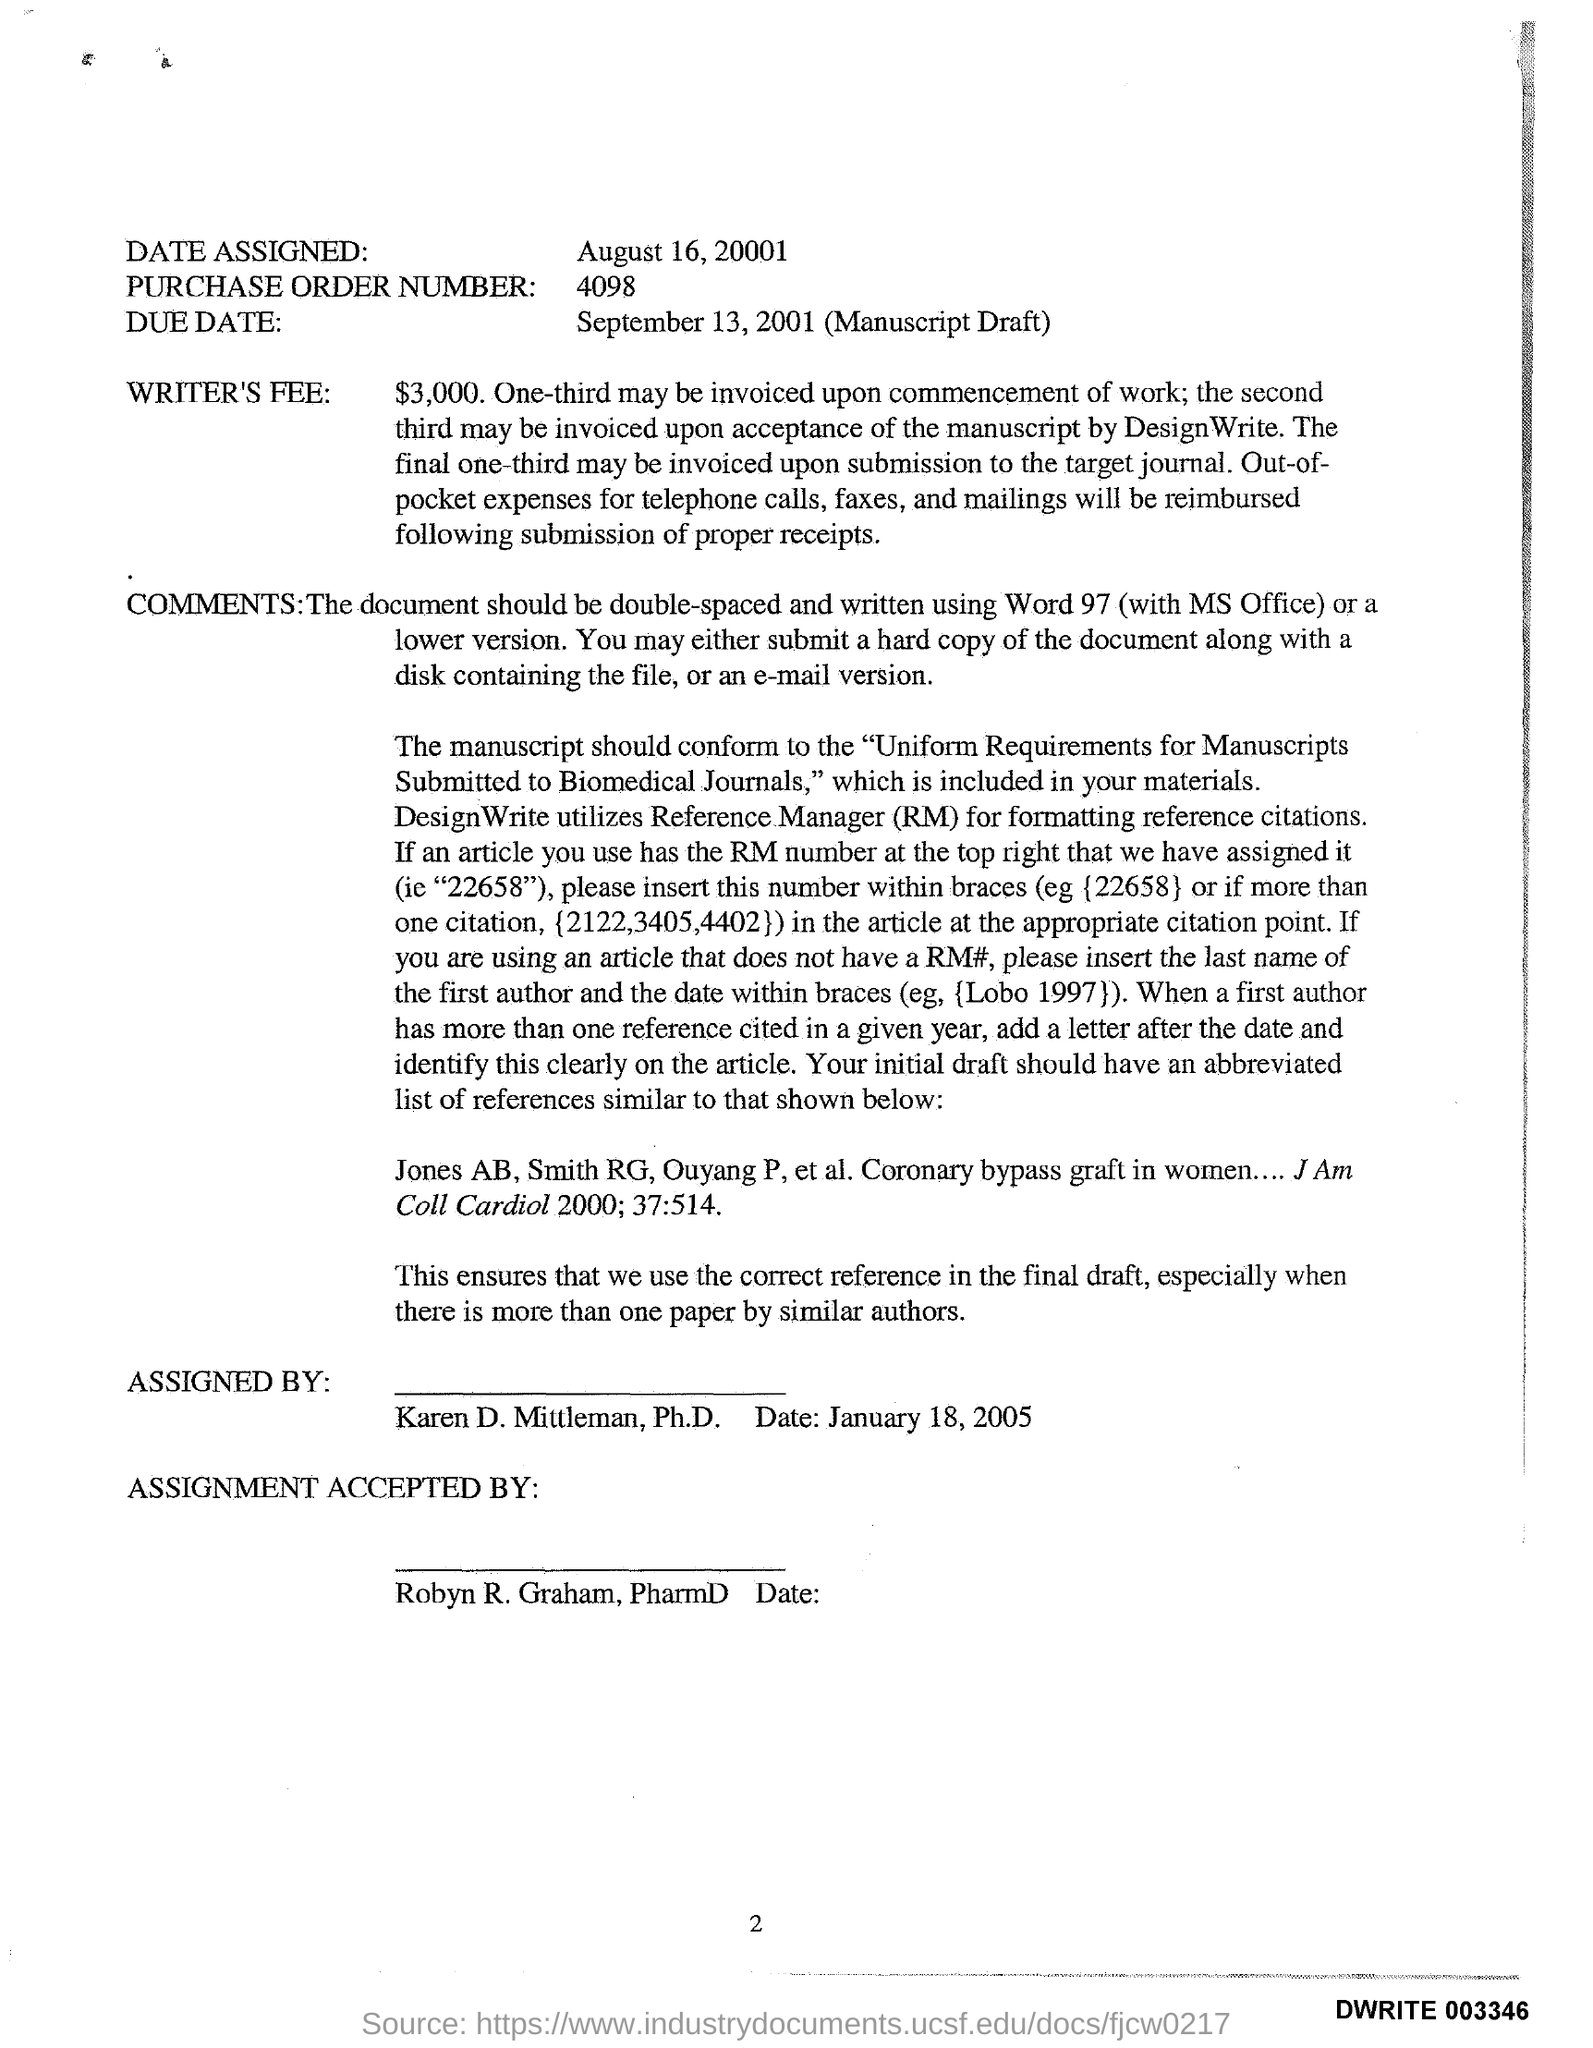Point out several critical features in this image. The phrase "what is the purchase Order number?" is a question asking for information. The number 4098 is provided as part of the request. The due date for the manuscript draft is September 13, 2001. The writer's fee is $3000. The date assigned is August 16, 2001. Robyn R. Graham, PharmD., accepted the assignment. 